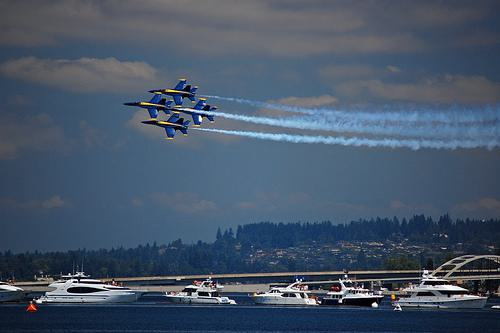Can you describe the event happening in the picture? The image captures a thrilling air show, featuring a squadron of jets flying in a tight formation. These are likely military jets, perhaps from a navy, performing at a special event as they exhibit precision flying and leave a synchronized trail of smoke, creating a spectacular view for onlookers. What kind of boats are present in the audience? The audience on the water includes a variety of boats, such as pleasure yachts, speedboats, and sailboats, all gathered at a safe distance to enjoy the air show. The diversity of boats suggests this is a popular public event, attracting enthusiasts and casual spectators alike. 